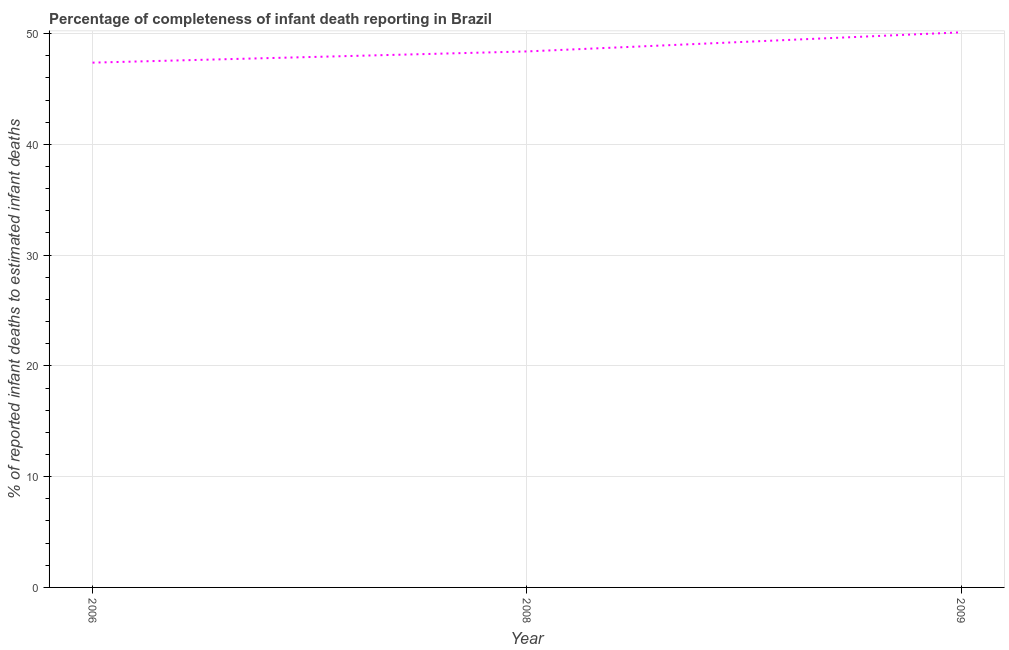What is the completeness of infant death reporting in 2006?
Your answer should be very brief. 47.38. Across all years, what is the maximum completeness of infant death reporting?
Offer a terse response. 50.12. Across all years, what is the minimum completeness of infant death reporting?
Your response must be concise. 47.38. In which year was the completeness of infant death reporting maximum?
Give a very brief answer. 2009. What is the sum of the completeness of infant death reporting?
Your answer should be compact. 145.89. What is the difference between the completeness of infant death reporting in 2008 and 2009?
Offer a terse response. -1.72. What is the average completeness of infant death reporting per year?
Give a very brief answer. 48.63. What is the median completeness of infant death reporting?
Make the answer very short. 48.39. In how many years, is the completeness of infant death reporting greater than 44 %?
Your answer should be very brief. 3. Do a majority of the years between 2009 and 2006 (inclusive) have completeness of infant death reporting greater than 22 %?
Your answer should be very brief. No. What is the ratio of the completeness of infant death reporting in 2006 to that in 2009?
Your answer should be very brief. 0.95. Is the difference between the completeness of infant death reporting in 2006 and 2008 greater than the difference between any two years?
Your answer should be compact. No. What is the difference between the highest and the second highest completeness of infant death reporting?
Provide a succinct answer. 1.72. Is the sum of the completeness of infant death reporting in 2006 and 2008 greater than the maximum completeness of infant death reporting across all years?
Your answer should be very brief. Yes. What is the difference between the highest and the lowest completeness of infant death reporting?
Offer a terse response. 2.74. How many lines are there?
Your answer should be compact. 1. How many years are there in the graph?
Keep it short and to the point. 3. Are the values on the major ticks of Y-axis written in scientific E-notation?
Offer a terse response. No. Does the graph contain any zero values?
Your response must be concise. No. What is the title of the graph?
Give a very brief answer. Percentage of completeness of infant death reporting in Brazil. What is the label or title of the Y-axis?
Your response must be concise. % of reported infant deaths to estimated infant deaths. What is the % of reported infant deaths to estimated infant deaths of 2006?
Give a very brief answer. 47.38. What is the % of reported infant deaths to estimated infant deaths of 2008?
Give a very brief answer. 48.39. What is the % of reported infant deaths to estimated infant deaths of 2009?
Ensure brevity in your answer.  50.12. What is the difference between the % of reported infant deaths to estimated infant deaths in 2006 and 2008?
Your answer should be compact. -1.01. What is the difference between the % of reported infant deaths to estimated infant deaths in 2006 and 2009?
Your response must be concise. -2.74. What is the difference between the % of reported infant deaths to estimated infant deaths in 2008 and 2009?
Offer a very short reply. -1.72. What is the ratio of the % of reported infant deaths to estimated infant deaths in 2006 to that in 2009?
Provide a short and direct response. 0.94. What is the ratio of the % of reported infant deaths to estimated infant deaths in 2008 to that in 2009?
Offer a terse response. 0.97. 